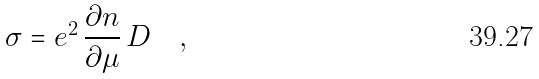Convert formula to latex. <formula><loc_0><loc_0><loc_500><loc_500>\sigma = e ^ { 2 } \, \frac { \partial n } { \partial \mu } \, D \quad ,</formula> 